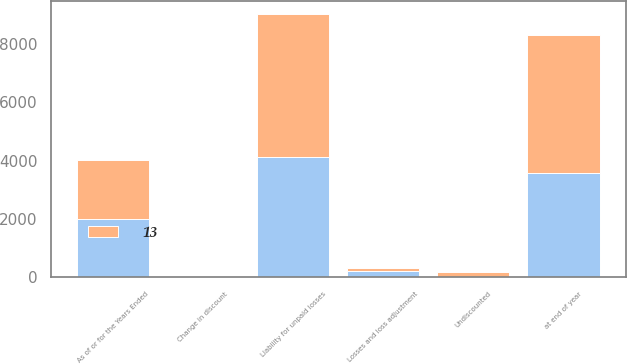Convert chart to OTSL. <chart><loc_0><loc_0><loc_500><loc_500><stacked_bar_chart><ecel><fcel>As of or for the Years Ended<fcel>Liability for unpaid losses<fcel>Undiscounted<fcel>Change in discount<fcel>Losses and loss adjustment<fcel>at end of year<nl><fcel>nan<fcel>2015<fcel>4117<fcel>13<fcel>9<fcel>214<fcel>3595<nl><fcel>13<fcel>2013<fcel>4896<fcel>169<fcel>51<fcel>98<fcel>4720<nl></chart> 